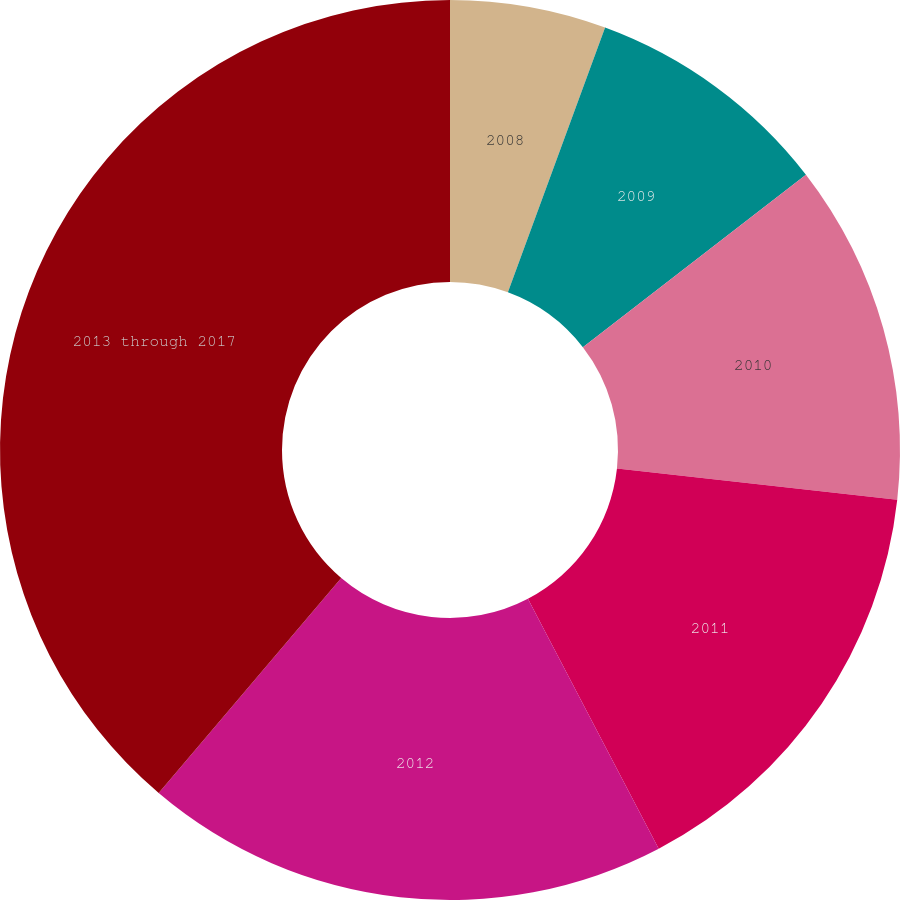Convert chart to OTSL. <chart><loc_0><loc_0><loc_500><loc_500><pie_chart><fcel>2008<fcel>2009<fcel>2010<fcel>2011<fcel>2012<fcel>2013 through 2017<nl><fcel>5.6%<fcel>8.92%<fcel>12.24%<fcel>15.56%<fcel>18.88%<fcel>38.79%<nl></chart> 